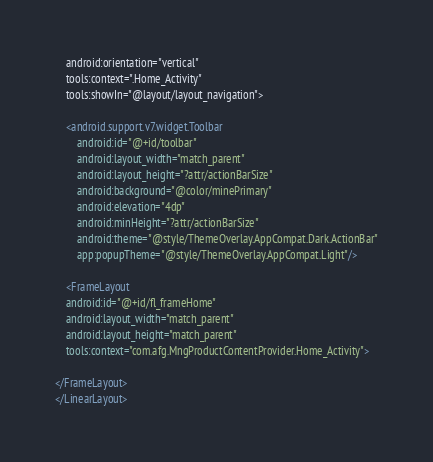<code> <loc_0><loc_0><loc_500><loc_500><_XML_>    android:orientation="vertical"
    tools:context=".Home_Activity"
    tools:showIn="@layout/layout_navigation">

    <android.support.v7.widget.Toolbar
        android:id="@+id/toolbar"
        android:layout_width="match_parent"
        android:layout_height="?attr/actionBarSize"
        android:background="@color/minePrimary"
        android:elevation="4dp"
        android:minHeight="?attr/actionBarSize"
        android:theme="@style/ThemeOverlay.AppCompat.Dark.ActionBar"
        app:popupTheme="@style/ThemeOverlay.AppCompat.Light"/>

    <FrameLayout
    android:id="@+id/fl_frameHome"
    android:layout_width="match_parent"
    android:layout_height="match_parent"
    tools:context="com.afg.MngProductContentProvider.Home_Activity">

</FrameLayout>
</LinearLayout></code> 